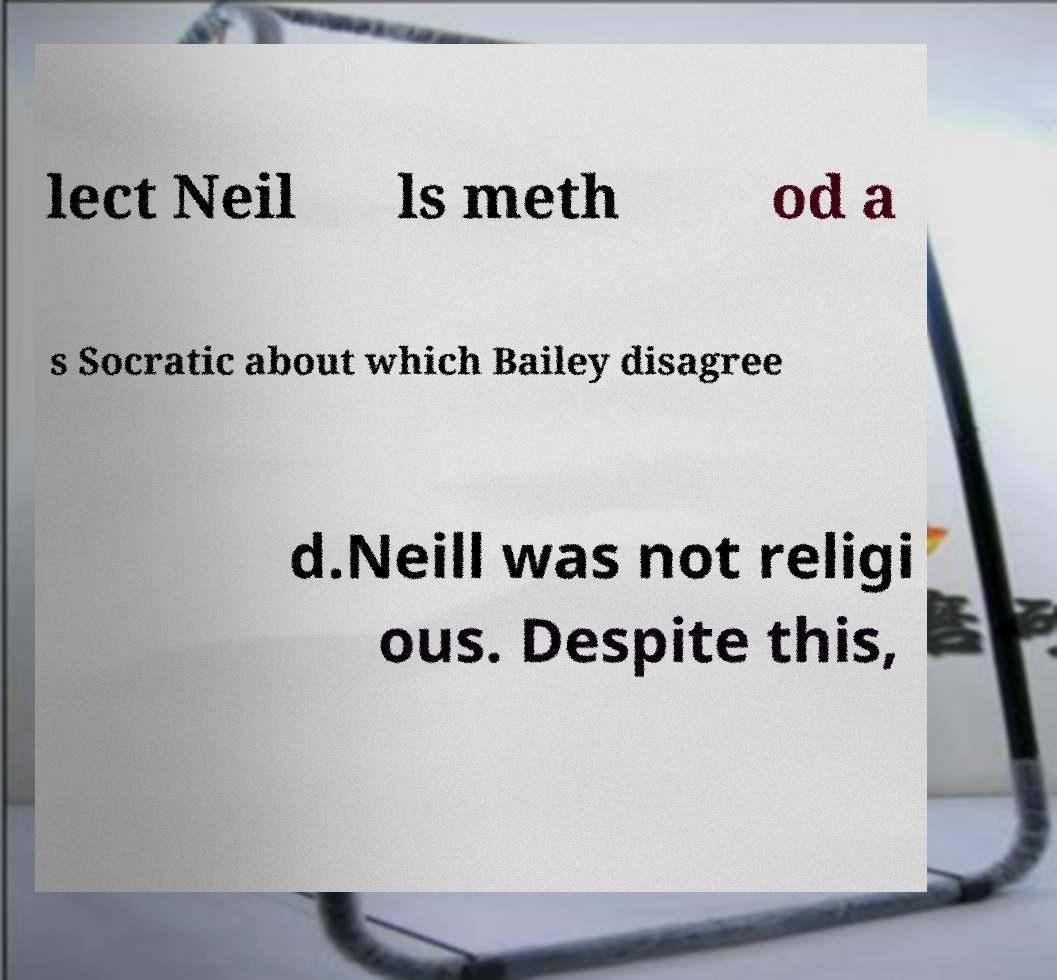Could you extract and type out the text from this image? lect Neil ls meth od a s Socratic about which Bailey disagree d.Neill was not religi ous. Despite this, 